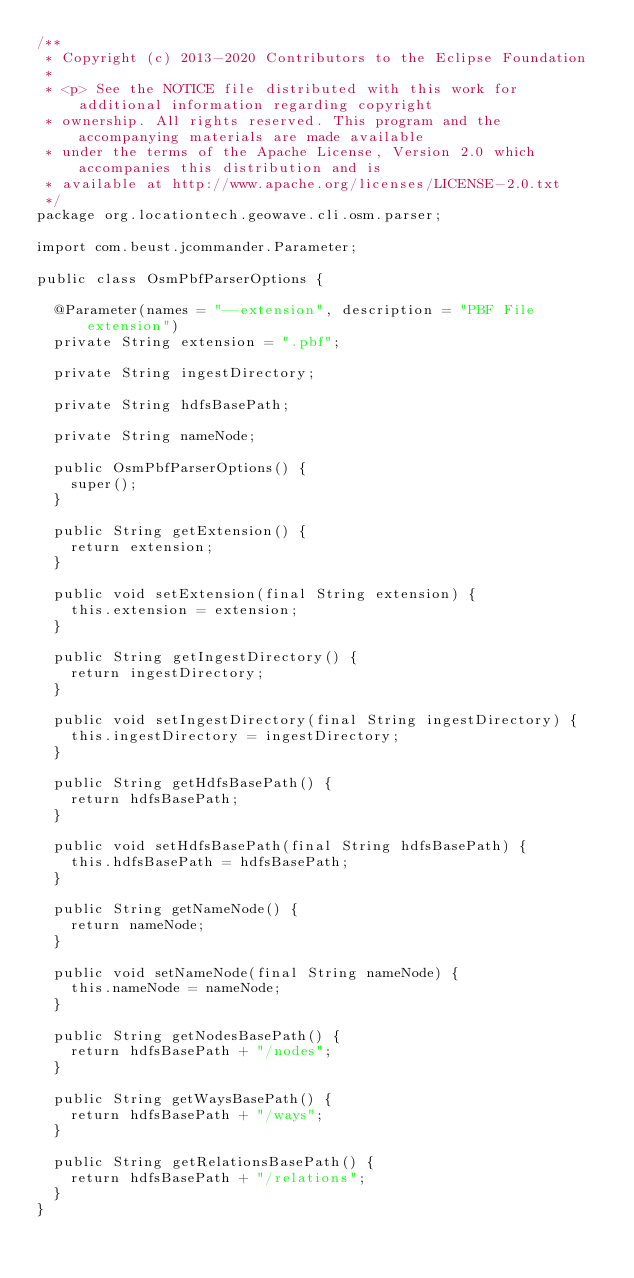<code> <loc_0><loc_0><loc_500><loc_500><_Java_>/**
 * Copyright (c) 2013-2020 Contributors to the Eclipse Foundation
 *
 * <p> See the NOTICE file distributed with this work for additional information regarding copyright
 * ownership. All rights reserved. This program and the accompanying materials are made available
 * under the terms of the Apache License, Version 2.0 which accompanies this distribution and is
 * available at http://www.apache.org/licenses/LICENSE-2.0.txt
 */
package org.locationtech.geowave.cli.osm.parser;

import com.beust.jcommander.Parameter;

public class OsmPbfParserOptions {

  @Parameter(names = "--extension", description = "PBF File extension")
  private String extension = ".pbf";

  private String ingestDirectory;

  private String hdfsBasePath;

  private String nameNode;

  public OsmPbfParserOptions() {
    super();
  }

  public String getExtension() {
    return extension;
  }

  public void setExtension(final String extension) {
    this.extension = extension;
  }

  public String getIngestDirectory() {
    return ingestDirectory;
  }

  public void setIngestDirectory(final String ingestDirectory) {
    this.ingestDirectory = ingestDirectory;
  }

  public String getHdfsBasePath() {
    return hdfsBasePath;
  }

  public void setHdfsBasePath(final String hdfsBasePath) {
    this.hdfsBasePath = hdfsBasePath;
  }

  public String getNameNode() {
    return nameNode;
  }

  public void setNameNode(final String nameNode) {
    this.nameNode = nameNode;
  }

  public String getNodesBasePath() {
    return hdfsBasePath + "/nodes";
  }

  public String getWaysBasePath() {
    return hdfsBasePath + "/ways";
  }

  public String getRelationsBasePath() {
    return hdfsBasePath + "/relations";
  }
}
</code> 